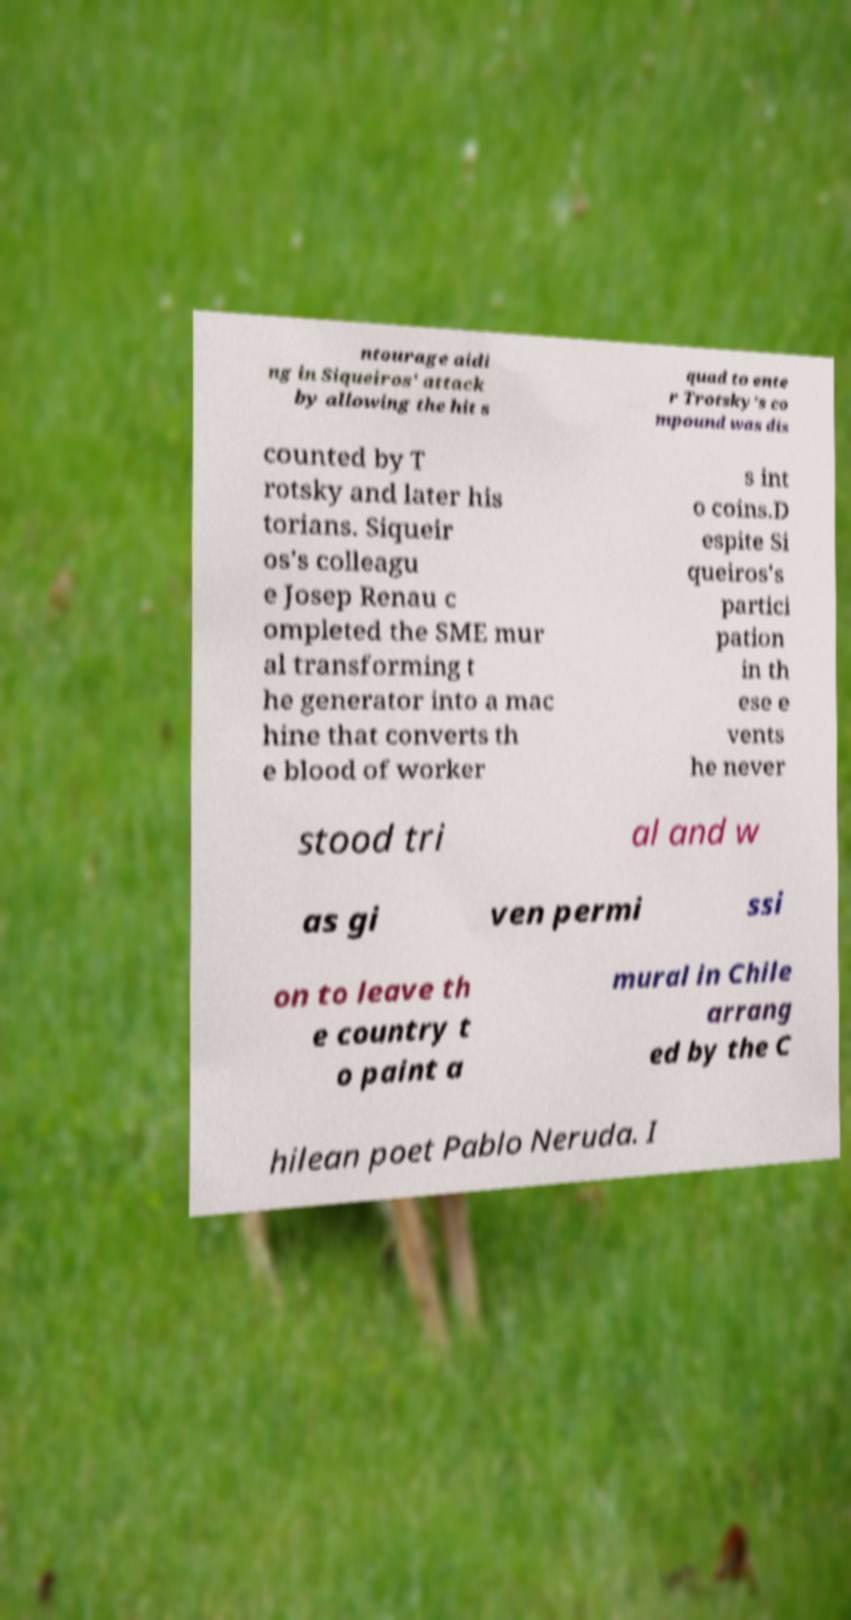Could you assist in decoding the text presented in this image and type it out clearly? ntourage aidi ng in Siqueiros' attack by allowing the hit s quad to ente r Trotsky's co mpound was dis counted by T rotsky and later his torians. Siqueir os's colleagu e Josep Renau c ompleted the SME mur al transforming t he generator into a mac hine that converts th e blood of worker s int o coins.D espite Si queiros's partici pation in th ese e vents he never stood tri al and w as gi ven permi ssi on to leave th e country t o paint a mural in Chile arrang ed by the C hilean poet Pablo Neruda. I 